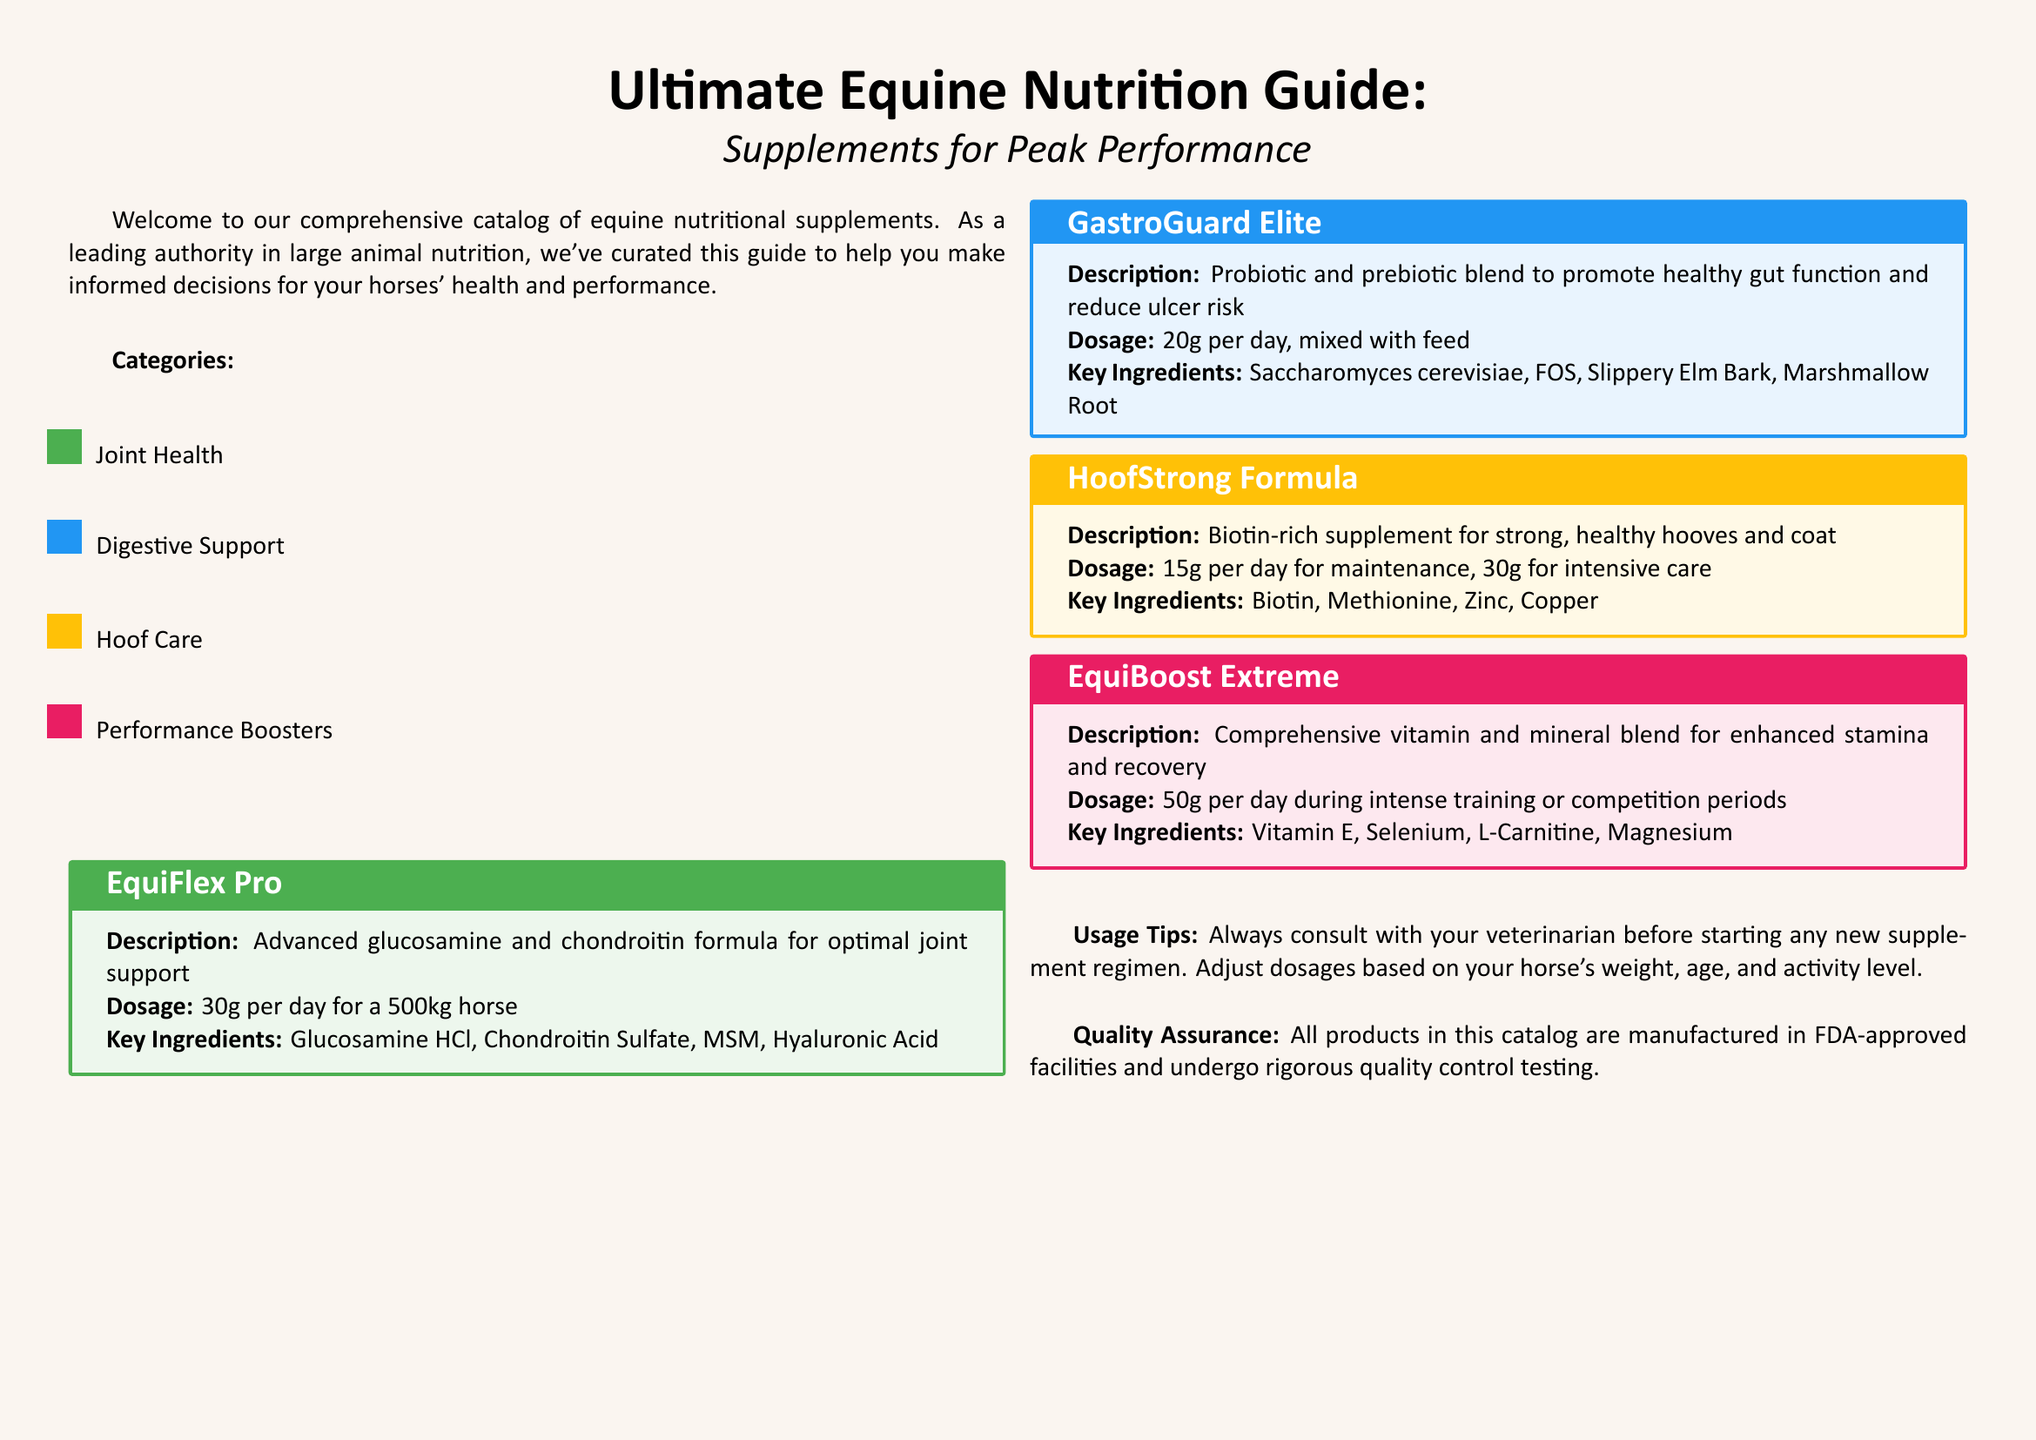What is the title of the catalog? The title appears at the top of the document, indicating the scope and purpose of the guide.
Answer: Ultimate Equine Nutrition Guide: Supplements for Peak Performance What is the dosage for EquiFlex Pro? The dosage is specified in the product description section for EquiFlex Pro.
Answer: 30g per day for a 500kg horse Which product supports gut function? The product's description notes its purpose in promoting healthy gut function, indicating its target area.
Answer: GastroGuard Elite How many key ingredients are listed for HoofStrong Formula? The number of key ingredients is mentioned in the product description for HoofStrong Formula.
Answer: Four What category does EquiBoost Extreme fall under? The category can be derived from the color-coded system used to classify the products in the catalog.
Answer: Performance Boosters What are the key ingredients of GastroGuard Elite? The key ingredients are outlined in the product's details, highlighting its formulation.
Answer: Saccharomyces cerevisiae, FOS, Slippery Elm Bark, Marshmallow Root Which supplement is biotin-rich? The description of the supplements specifies which one is high in biotin, characterizing its focus area.
Answer: HoofStrong Formula What color represents Digestive Support? The color coding for categories is detailed in the introduction section of the catalog.
Answer: Blue 